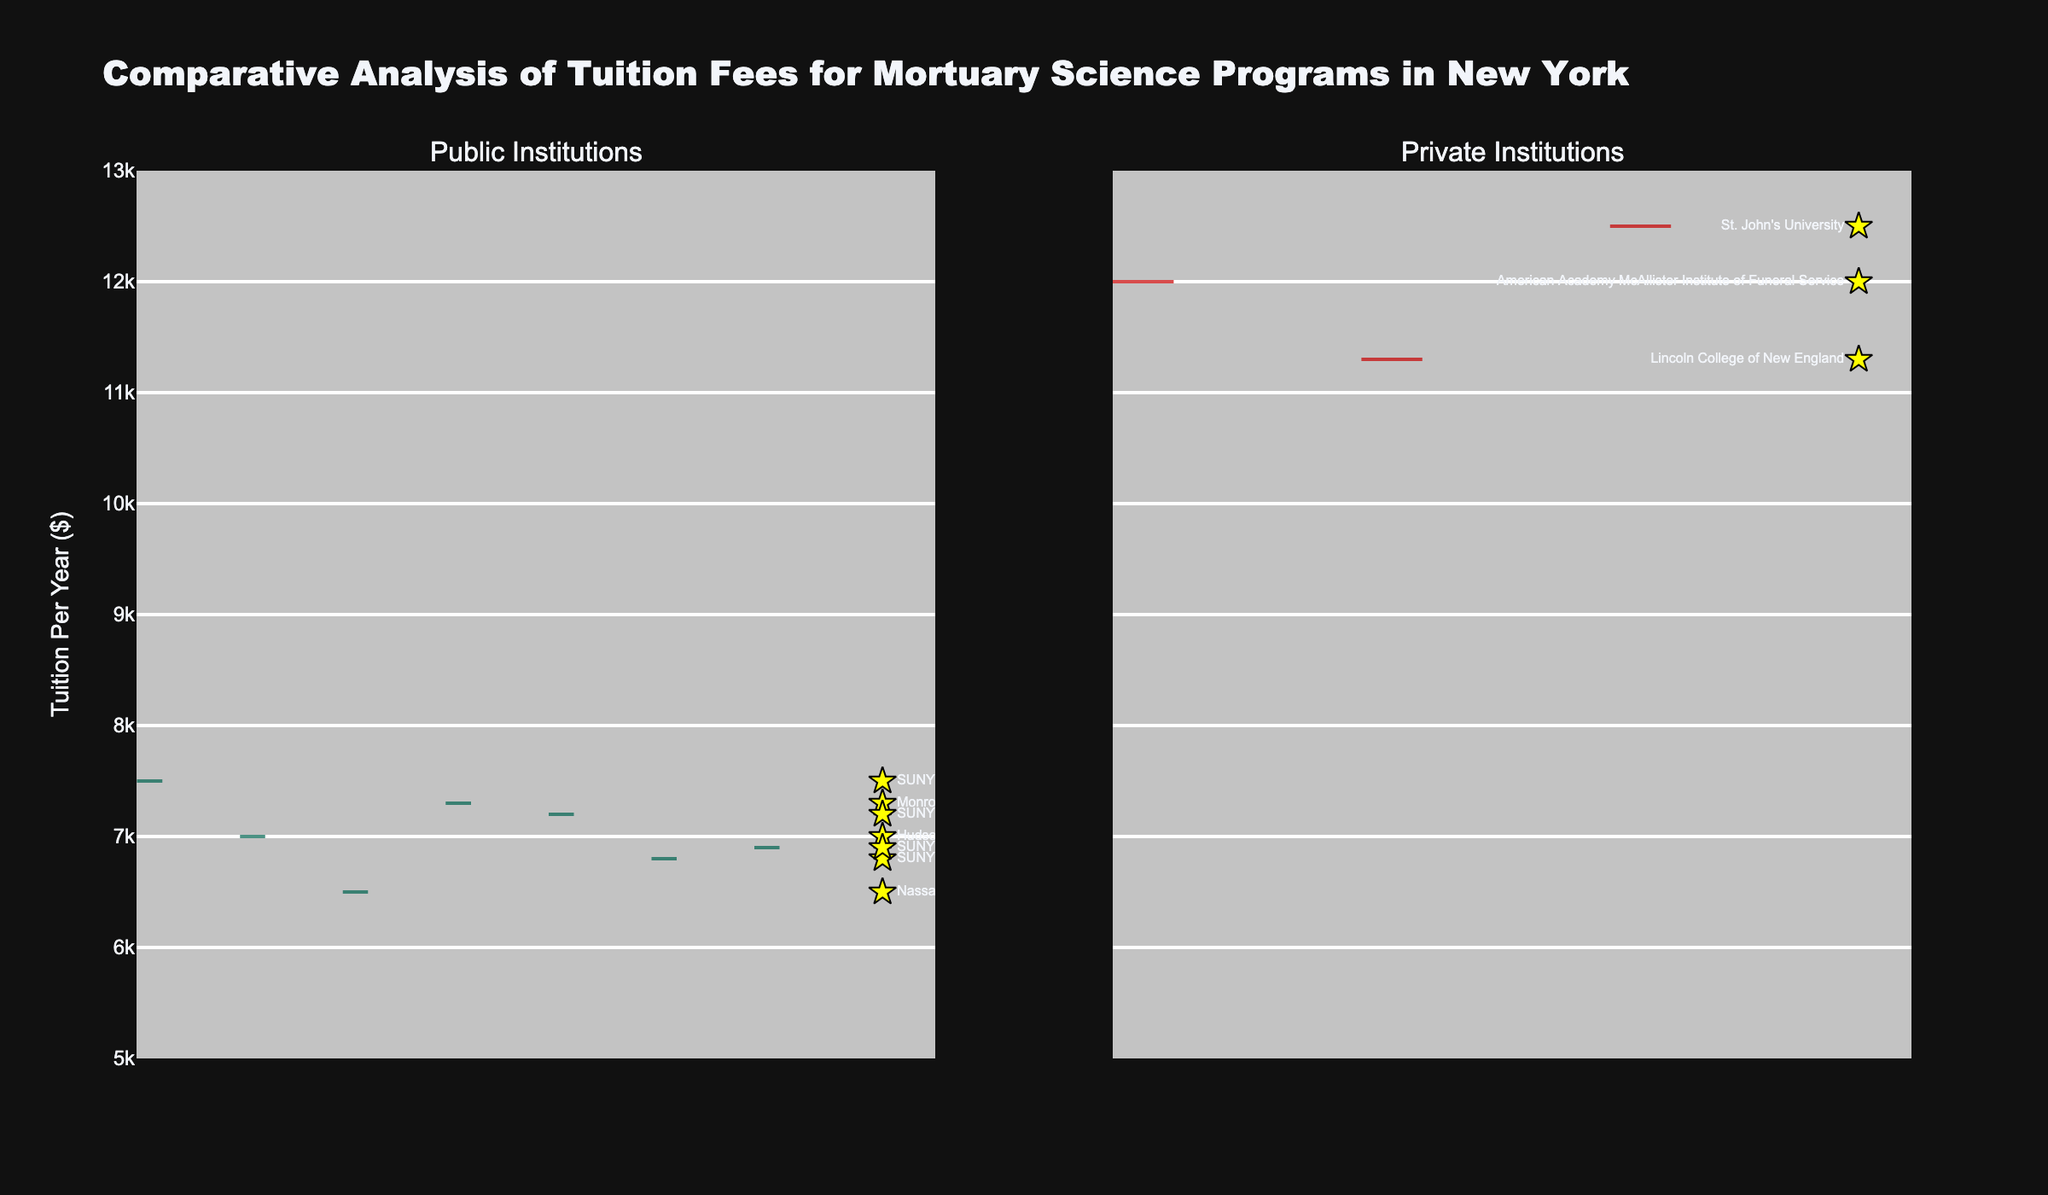What's the highest tuition fee for public institutions? The highest tuition fee for public institutions is depicted on the positive part of the split violin plot under 'Public Institutions'. The tuition is around $7500 for SUNY Canton.
Answer: $7500 What is the main difference shown between tuition fees of public vs private institutions? The split violin chart shows that private institutions tend to have higher tuition fees with a range from around $12000 to $12500, whereas public institutions range from approximately $6500 to $7500.
Answer: Private institutions have higher tuition fees Which institution has the lowest tuition fee among all? By observing the lowest point on the split violin plots, Nassau Community College under 'Public Institutions' has the lowest annual tuition fee, which is $6500.
Answer: Nassau Community College What's the average tuition fee for private institutions? To find the average: Sum of tuition fees of private institutions (12000 for American Academy McAllister + 11300 for Lincoln College of New England + 12500 for St. John's) = 35800. Divide this sum by the number of private institutions (3). 35800/3 = approximately 11933.33.
Answer: $11,933.33 What is the tuition difference between American Academy McAllister Institute of Funeral Service and SUNY Erie Community College? The tuition fee for American Academy McAllister Institute of Funeral Service is $12000, and for SUNY Erie Community College it is $6800. The difference is 12000 - 6800 = $5200.
Answer: $5200 How many institutions in total are depicted in the chart? Summarizing all points on both sides of the split violin chart, there are a total of 10 institutions displayed.
Answer: 10 Which institution offers a tuition fee closest to $7000? Observing the scattered points near $7000 on the public institutions side of the split violin plot, Hudson Valley Community College has a tuition fee of $7000.
Answer: Hudson Valley Community College Is there any overlap in the tuition fees between public and private institutions? There is no overlap as the lowest tuition fee for private institutions starts around $11300, and the highest fee for public institutions is around $7500, shown as distinct parts in the split violin chart.
Answer: No Which side of the split violin chart has larger variability in tuition fees? The private institutions show a larger variability in tuition fees, with values ranging from $11300 to $12500, compared to the narrower range of $6500 to $7500 for public institutions.
Answer: Private institutions 